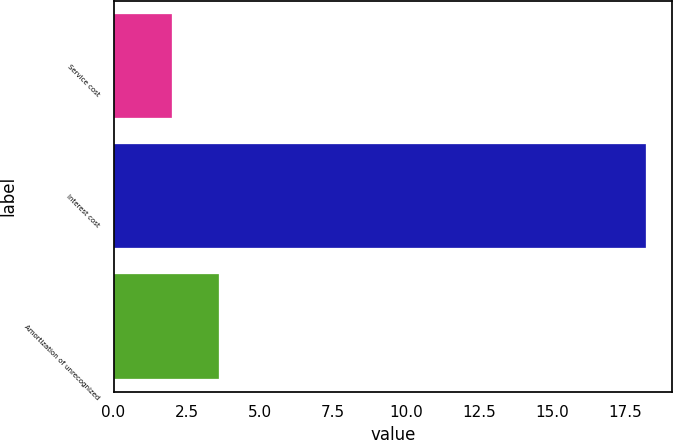Convert chart. <chart><loc_0><loc_0><loc_500><loc_500><bar_chart><fcel>Service cost<fcel>Interest cost<fcel>Amortization of unrecognized<nl><fcel>2<fcel>18.2<fcel>3.62<nl></chart> 